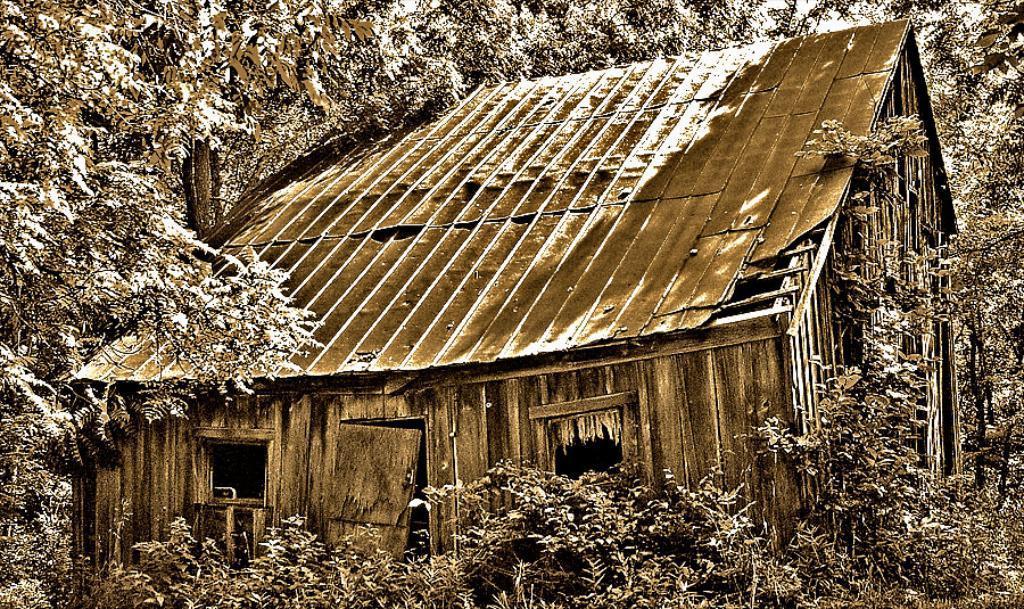Could you give a brief overview of what you see in this image? In this image I can see number of trees and some snow on the trees. I can see a brown colored house in between the trees and some snow on the roof of the house. 